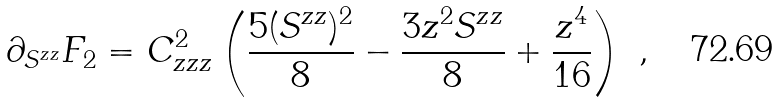Convert formula to latex. <formula><loc_0><loc_0><loc_500><loc_500>\partial _ { S ^ { z z } } F _ { 2 } = C ^ { 2 } _ { z z z } \left ( \frac { 5 ( S ^ { z z } ) ^ { 2 } } { 8 } - \frac { 3 z ^ { 2 } S ^ { z z } } { 8 } + \frac { z ^ { 4 } } { 1 6 } \right ) \ ,</formula> 